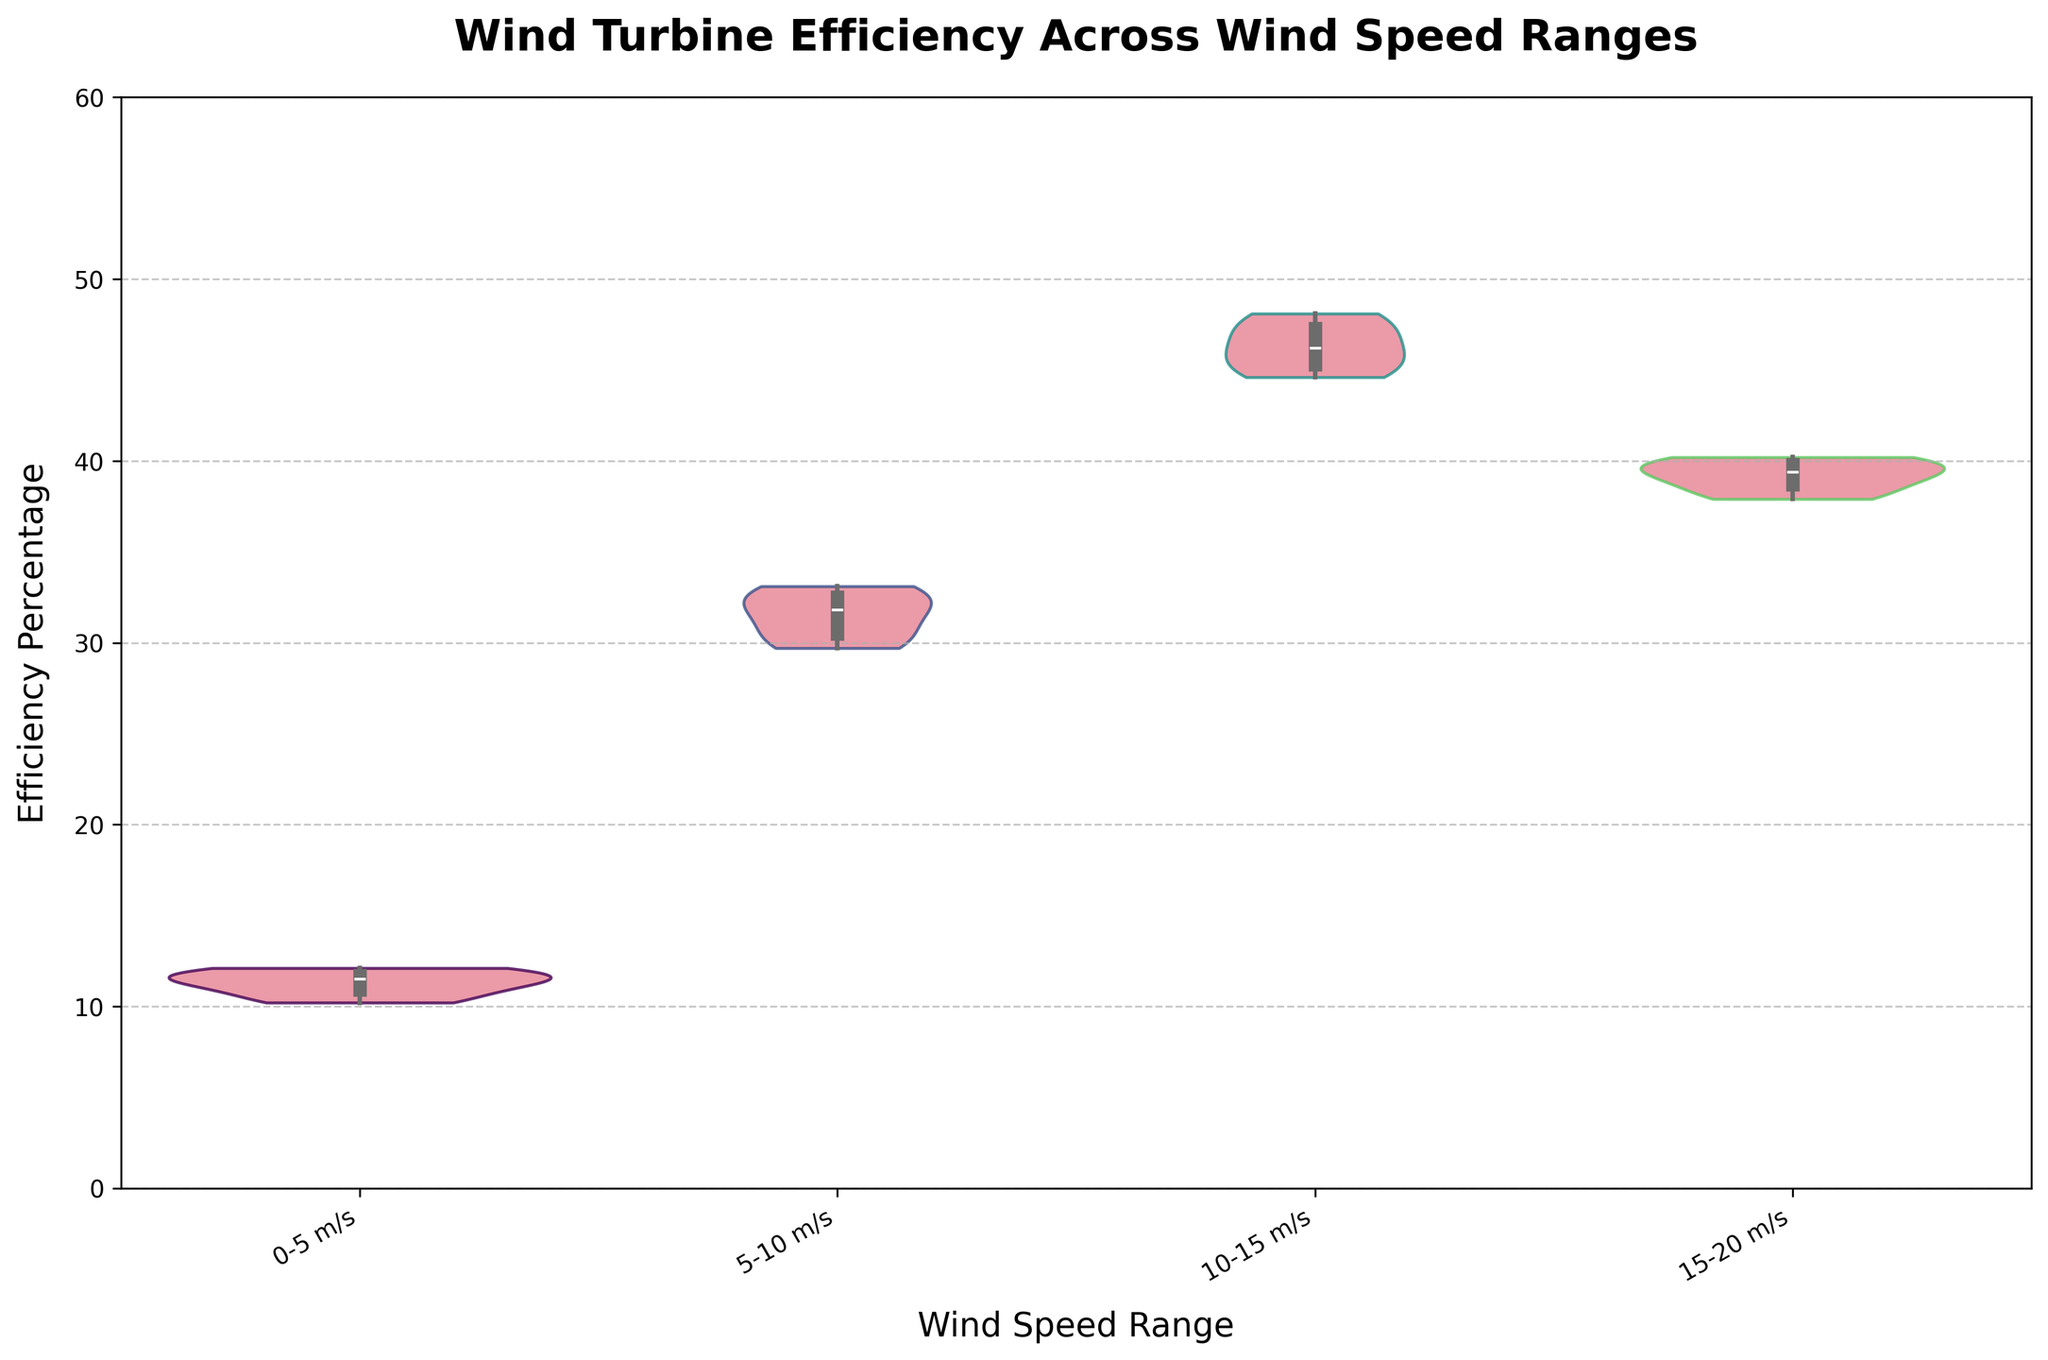What is the title of the chart? The title of the chart is displayed at the top center of the figure, written in bold.
Answer: Wind Turbine Efficiency Across Wind Speed Ranges What are the wind speed ranges displayed on the x-axis? The wind speed ranges are labeled along the x-axis in a slightly rotated manner for better readability. The ranges include 0-5 m/s, 5-10 m/s, 10-15 m/s, and 15-20 m/s.
Answer: 0-5 m/s, 5-10 m/s, 10-15 m/s, 15-20 m/s Which wind speed range has the highest median efficiency percentage? The violin plot displays the median as a white dot inside each violin. By comparing the positions of the white dots across the ranges, you can identify the one corresponding to the highest median efficiency.
Answer: 10-15 m/s How does the distribution of efficiency percentages change as wind speed increases? By observing the shape and spread of the violins, you can see that the distribution tightens and shifts higher as wind speed increases from 0-5 m/s to 10-15 m/s and then shows a different pattern for 15-20 m/s.
Answer: The distribution becomes tighter and shifts higher until 10-15 m/s, then changes for 15-20 m/s Which wind speed range shows the widest distribution of efficiency percentages? The width of the violin indicates the distribution spread. The range with the widest section indicates the greatest variance.
Answer: 0-5 m/s How does the mid-range (5-10 m/s) efficiency distribution compare to that of the highest efficiency range (10-15 m/s)? Compare the shape, width, and height of the violins between 5-10 m/s and 10-15 m/s ranges. The mid-range narrowens compared to the 0-5 m/s and shifts upwards, but is generally tighter and less dispersed than the highest efficiency range.
Answer: 5-10 m/s is generally tighter and higher than 0-5 m/s but less than 10-15 m/s What is the approximate range of efficiency percentages for the 15-20 m/s wind speed range? The extent of the violin from its lowest point to its highest point indicates the efficiency range. The exact values can be approximated from the y-axis.
Answer: Approximately 37.9% to 40.2% Is there any overlap between the efficiency distributions at different wind speed ranges? Checking the edges and spread of the violins, you can identify overlaps where distributions intersect.
Answer: Minimal overlap, primarily separate Between which two wind speed ranges is the difference in median efficiency percentage the most noticeable? Comparing the vertical positions of white dots (medians) between each pair of wind speed ranges, you can see the largest difference. The step from 10-15 m/s to 15-20 m/s shows the most significant change downward.
Answer: 10-15 m/s and 15-20 m/s 